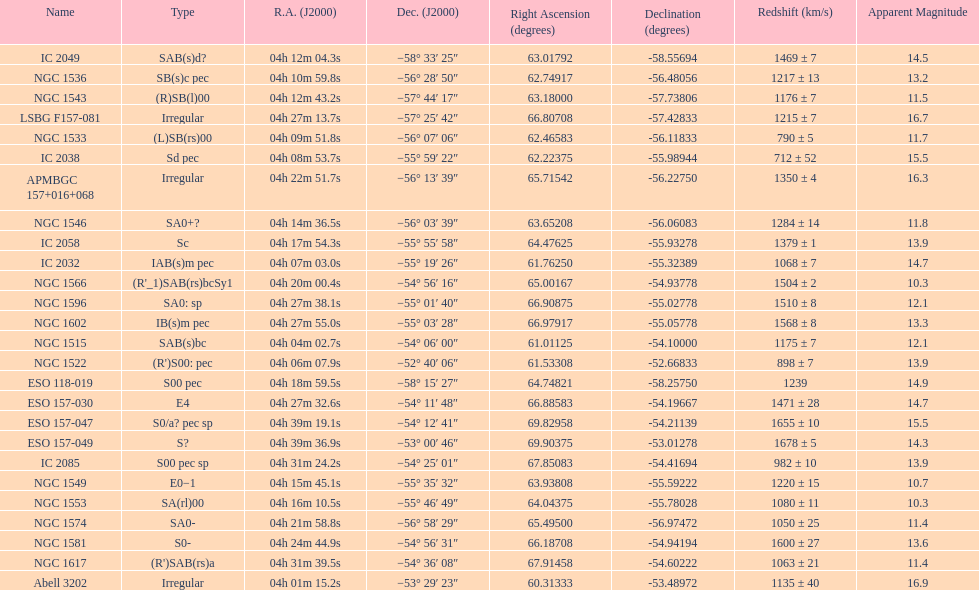Name the member with the highest apparent magnitude. Abell 3202. 